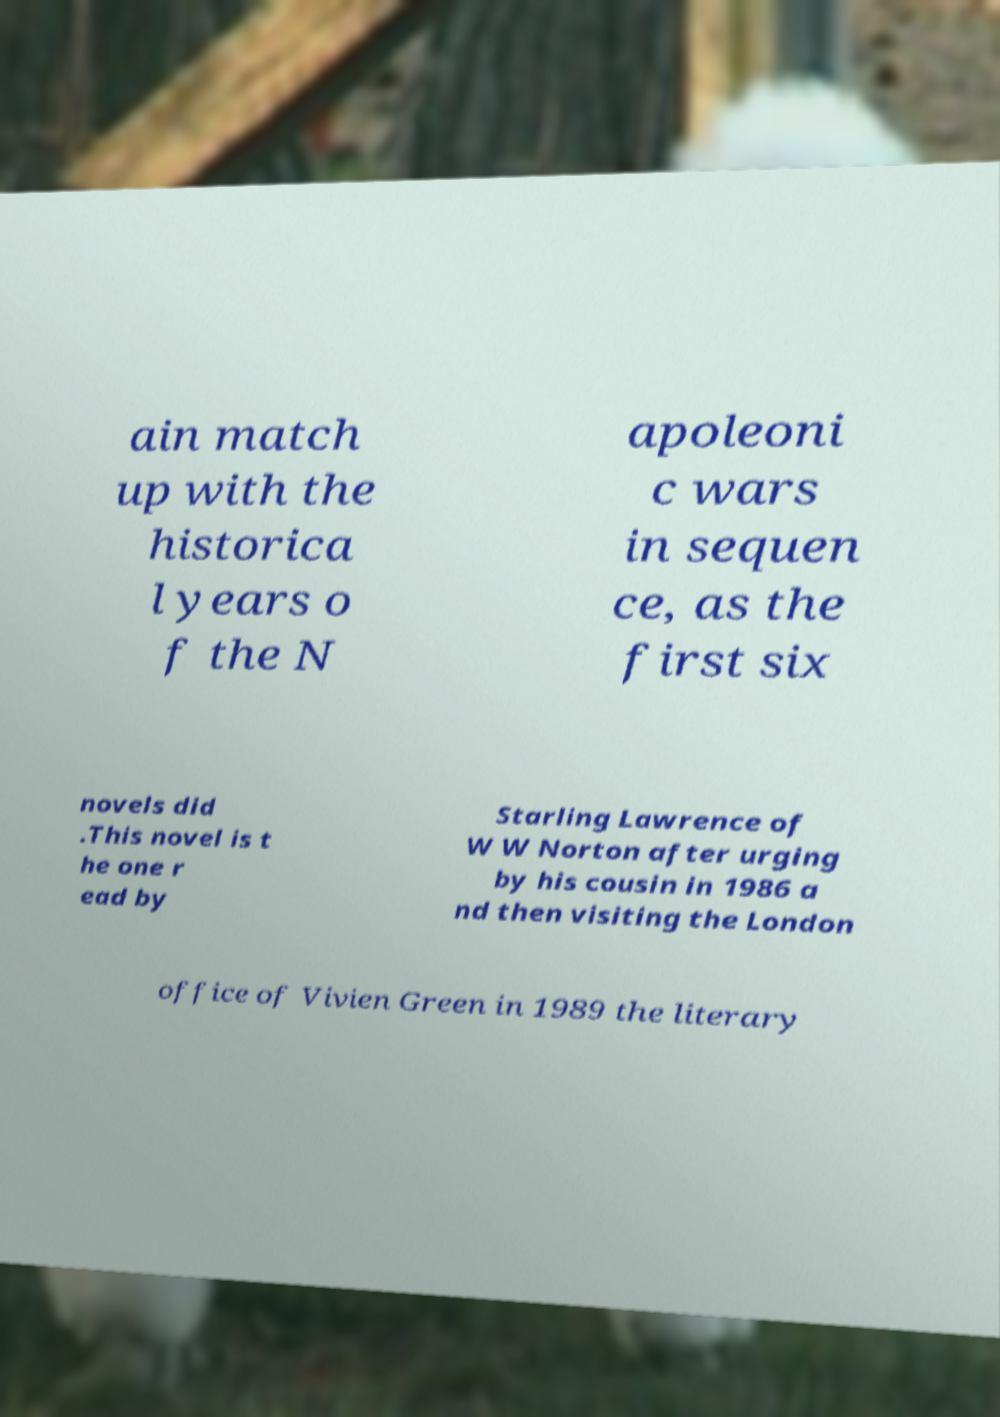Can you read and provide the text displayed in the image?This photo seems to have some interesting text. Can you extract and type it out for me? ain match up with the historica l years o f the N apoleoni c wars in sequen ce, as the first six novels did .This novel is t he one r ead by Starling Lawrence of W W Norton after urging by his cousin in 1986 a nd then visiting the London office of Vivien Green in 1989 the literary 